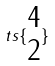Convert formula to latex. <formula><loc_0><loc_0><loc_500><loc_500>t s \{ \begin{matrix} 4 \\ 2 \end{matrix} \}</formula> 